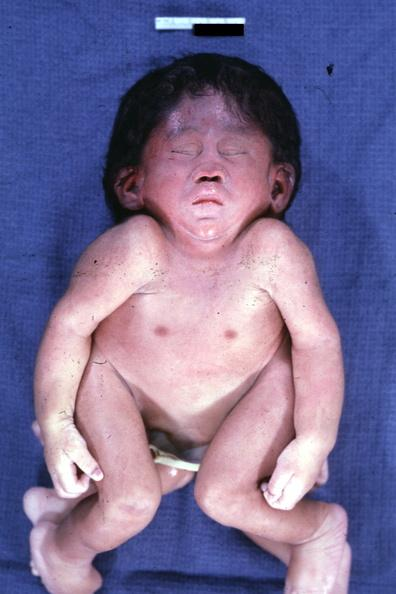what is this to illustrate this case externally?
Answer the question using a single word or phrase. The best photo 